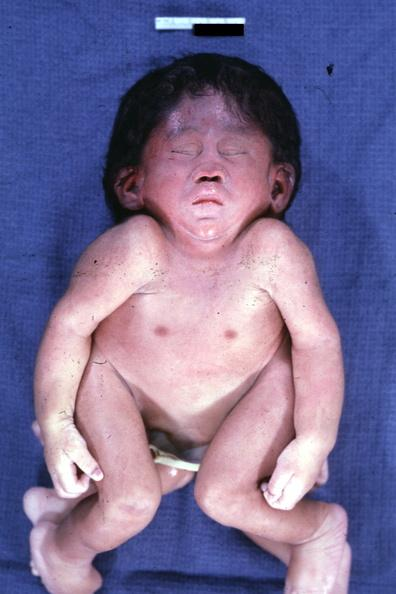what is this to illustrate this case externally?
Answer the question using a single word or phrase. The best photo 